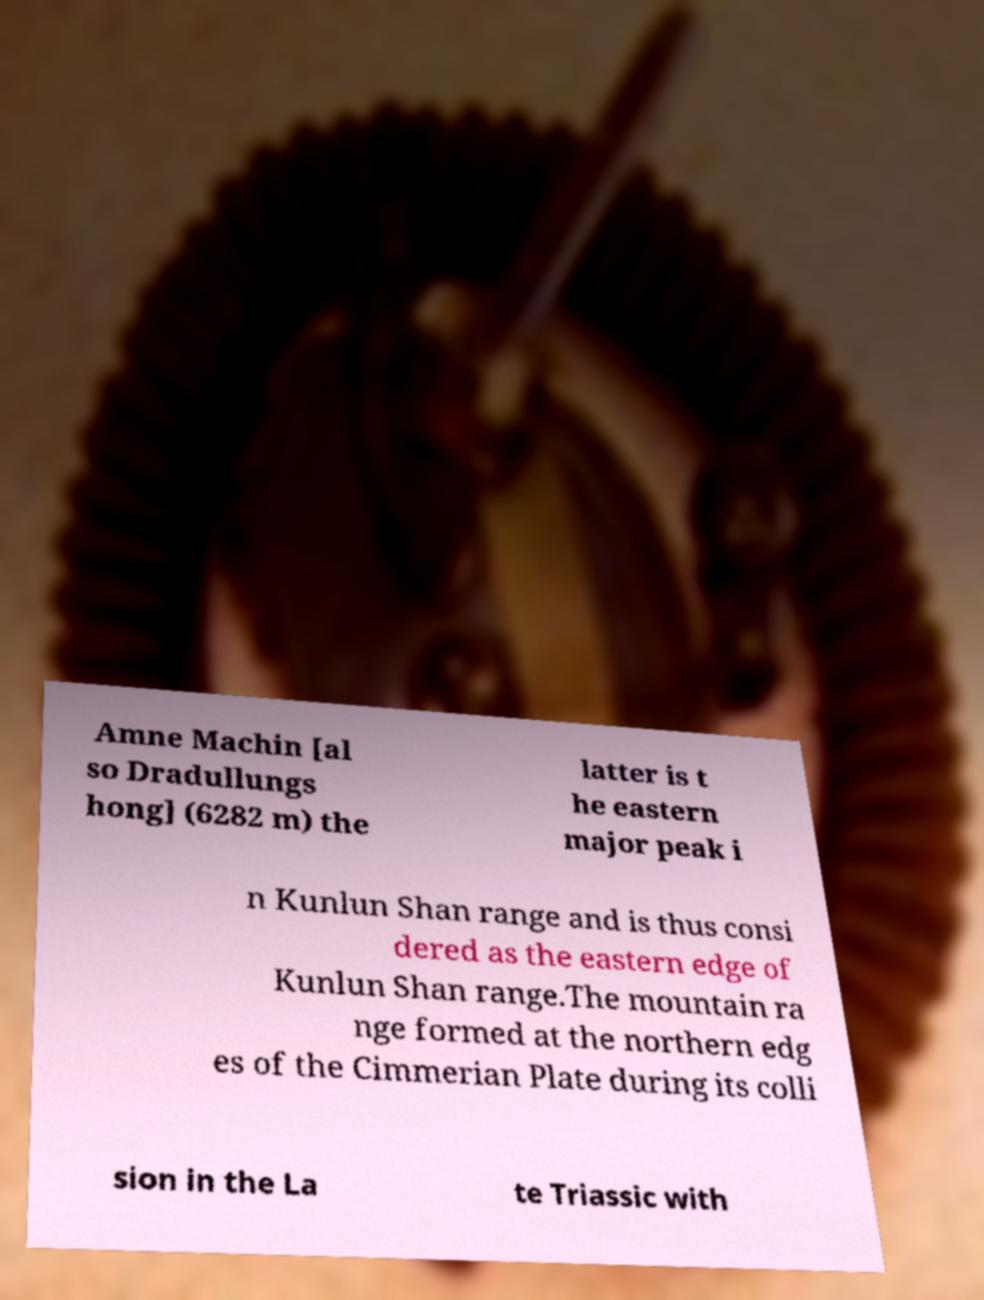Please identify and transcribe the text found in this image. Amne Machin [al so Dradullungs hong] (6282 m) the latter is t he eastern major peak i n Kunlun Shan range and is thus consi dered as the eastern edge of Kunlun Shan range.The mountain ra nge formed at the northern edg es of the Cimmerian Plate during its colli sion in the La te Triassic with 